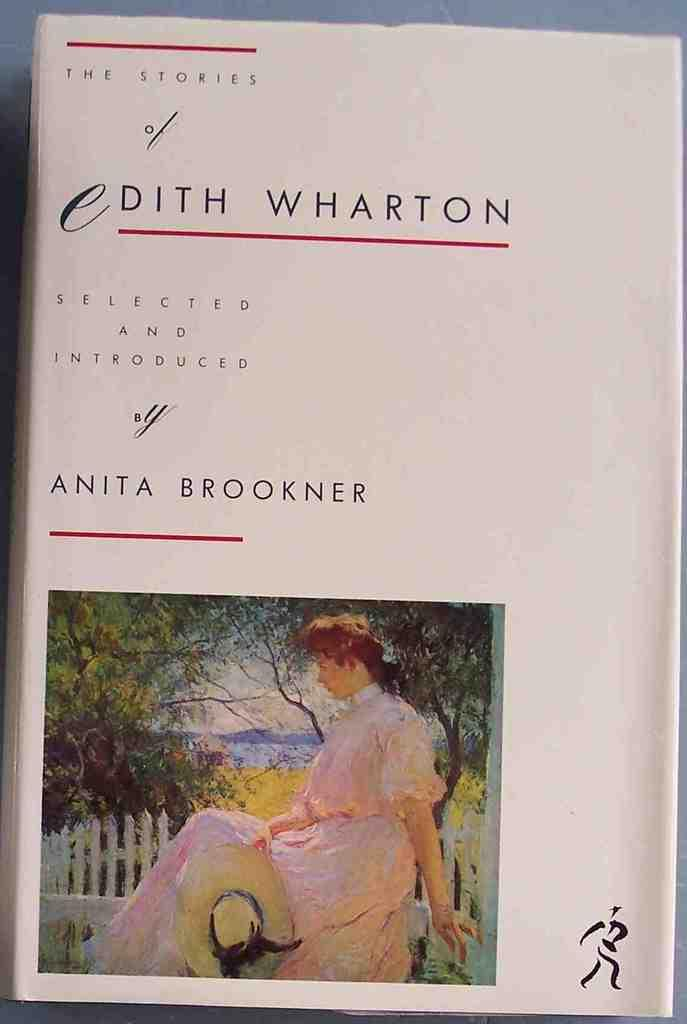<image>
Share a concise interpretation of the image provided. book called edith wharton by anita brookner it looks old 